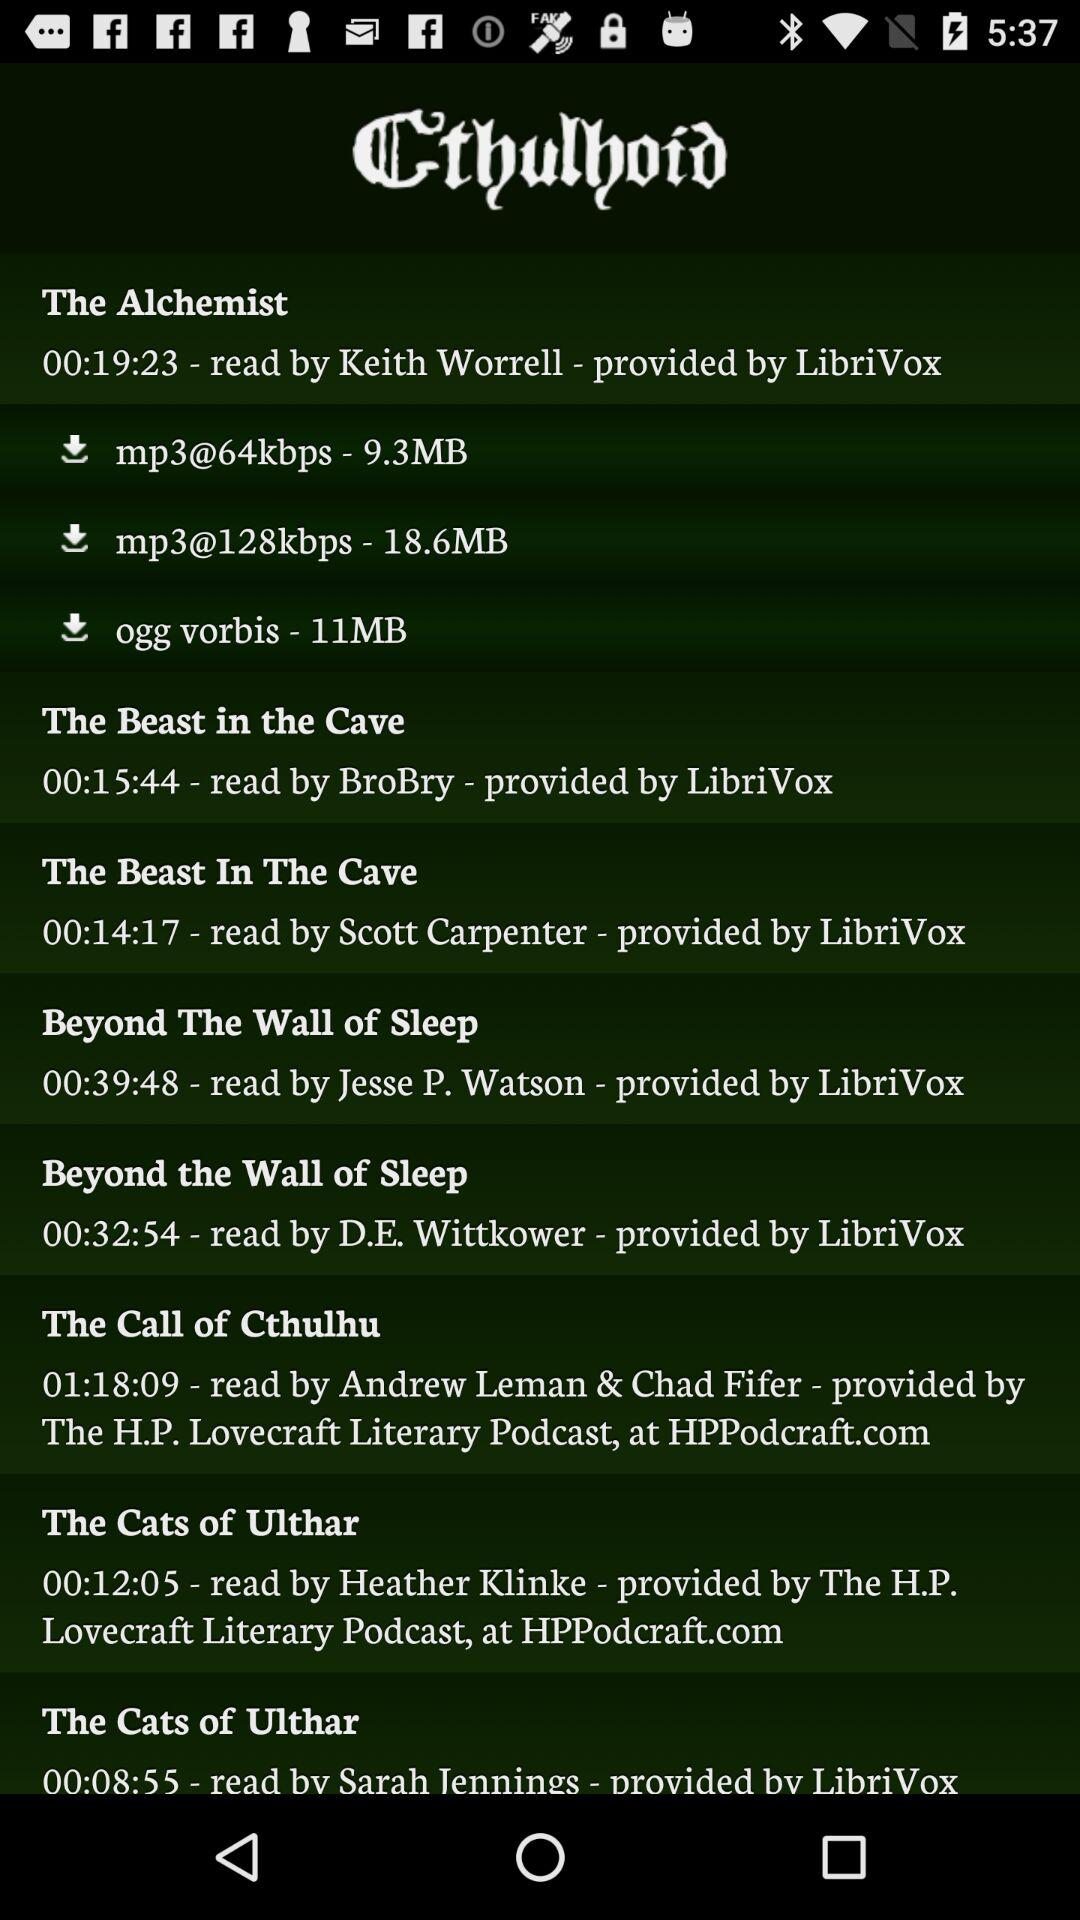Who is the provider of the "The Beast In The Cave" audiobook? The provider of the "The Beast In The Cave" audiobook is "LibriVox". 